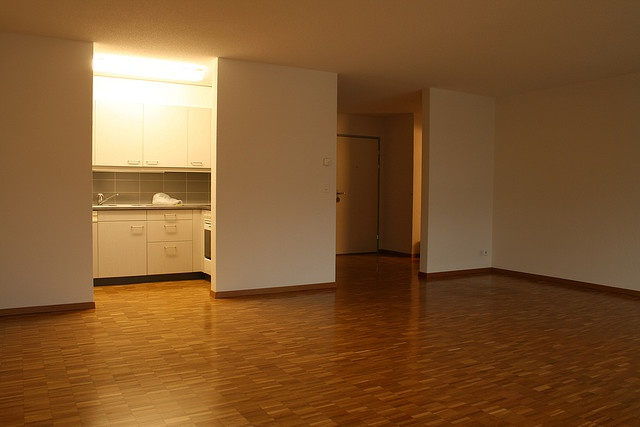Describe the objects in this image and their specific colors. I can see oven in maroon, tan, and khaki tones and sink in maroon, olive, tan, and khaki tones in this image. 